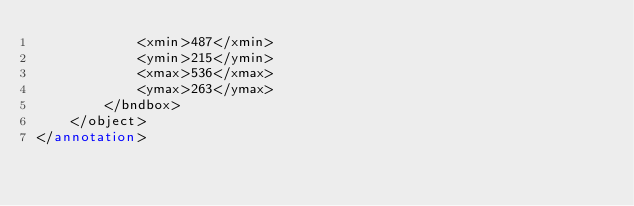<code> <loc_0><loc_0><loc_500><loc_500><_XML_>			<xmin>487</xmin>
			<ymin>215</ymin>
			<xmax>536</xmax>
			<ymax>263</ymax>
		</bndbox>
	</object>
</annotation>
</code> 